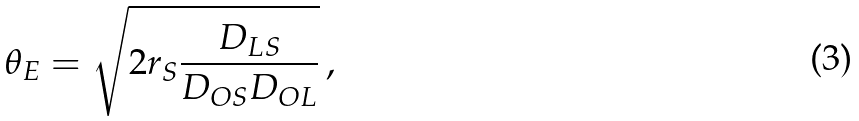Convert formula to latex. <formula><loc_0><loc_0><loc_500><loc_500>\theta _ { E } = \sqrt { 2 r _ { S } \frac { D _ { L S } } { D _ { O S } D _ { O L } } } \, ,</formula> 